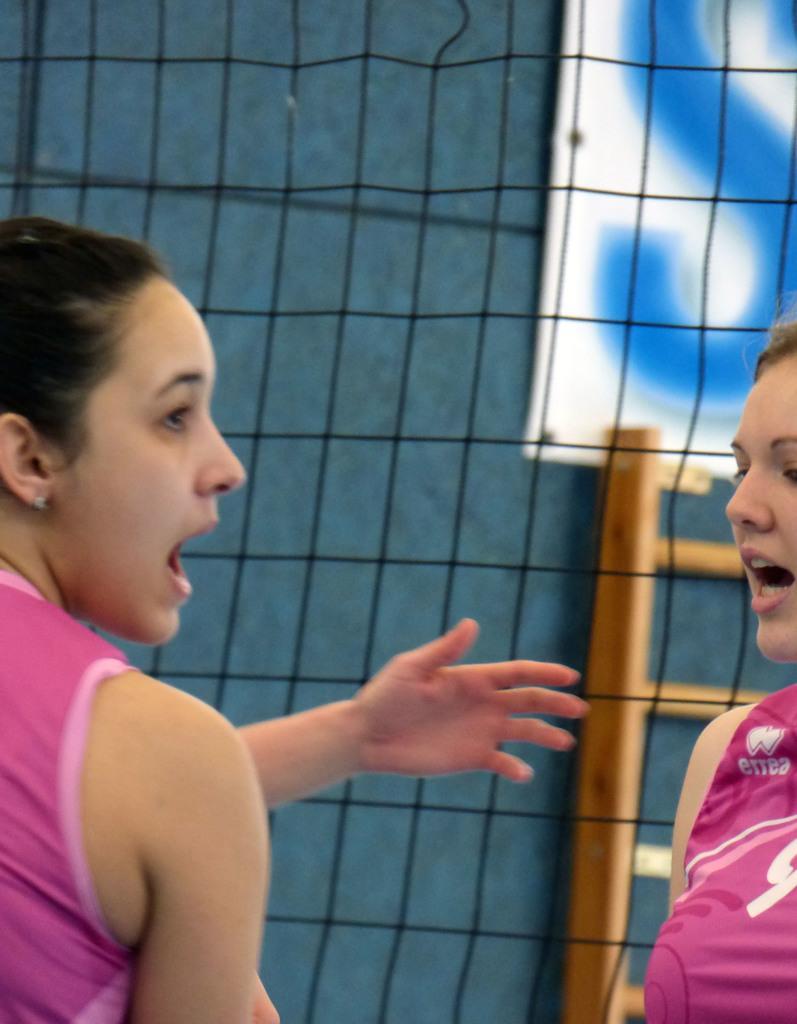Please provide a concise description of this image. In this image I can see two persons. There is a sports net, a ladder and in the top right corner it looks like a banner or a board. 